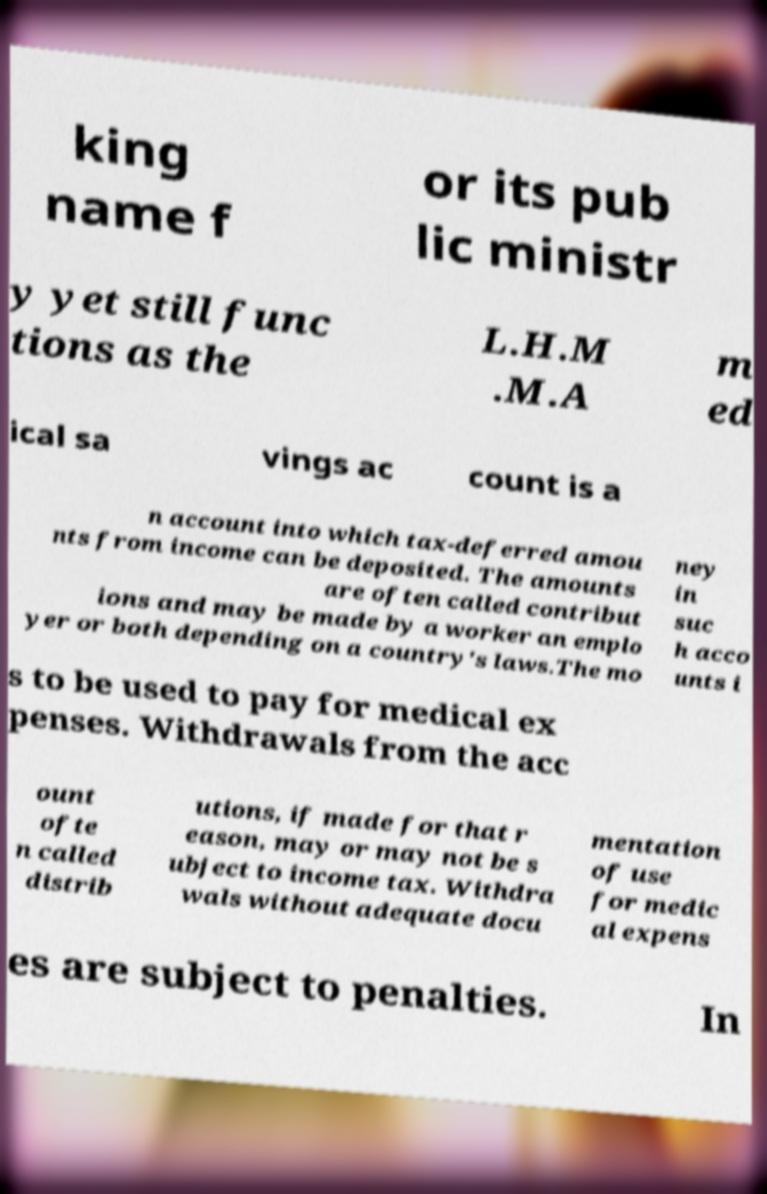There's text embedded in this image that I need extracted. Can you transcribe it verbatim? king name f or its pub lic ministr y yet still func tions as the L.H.M .M.A m ed ical sa vings ac count is a n account into which tax-deferred amou nts from income can be deposited. The amounts are often called contribut ions and may be made by a worker an emplo yer or both depending on a country's laws.The mo ney in suc h acco unts i s to be used to pay for medical ex penses. Withdrawals from the acc ount ofte n called distrib utions, if made for that r eason, may or may not be s ubject to income tax. Withdra wals without adequate docu mentation of use for medic al expens es are subject to penalties. In 